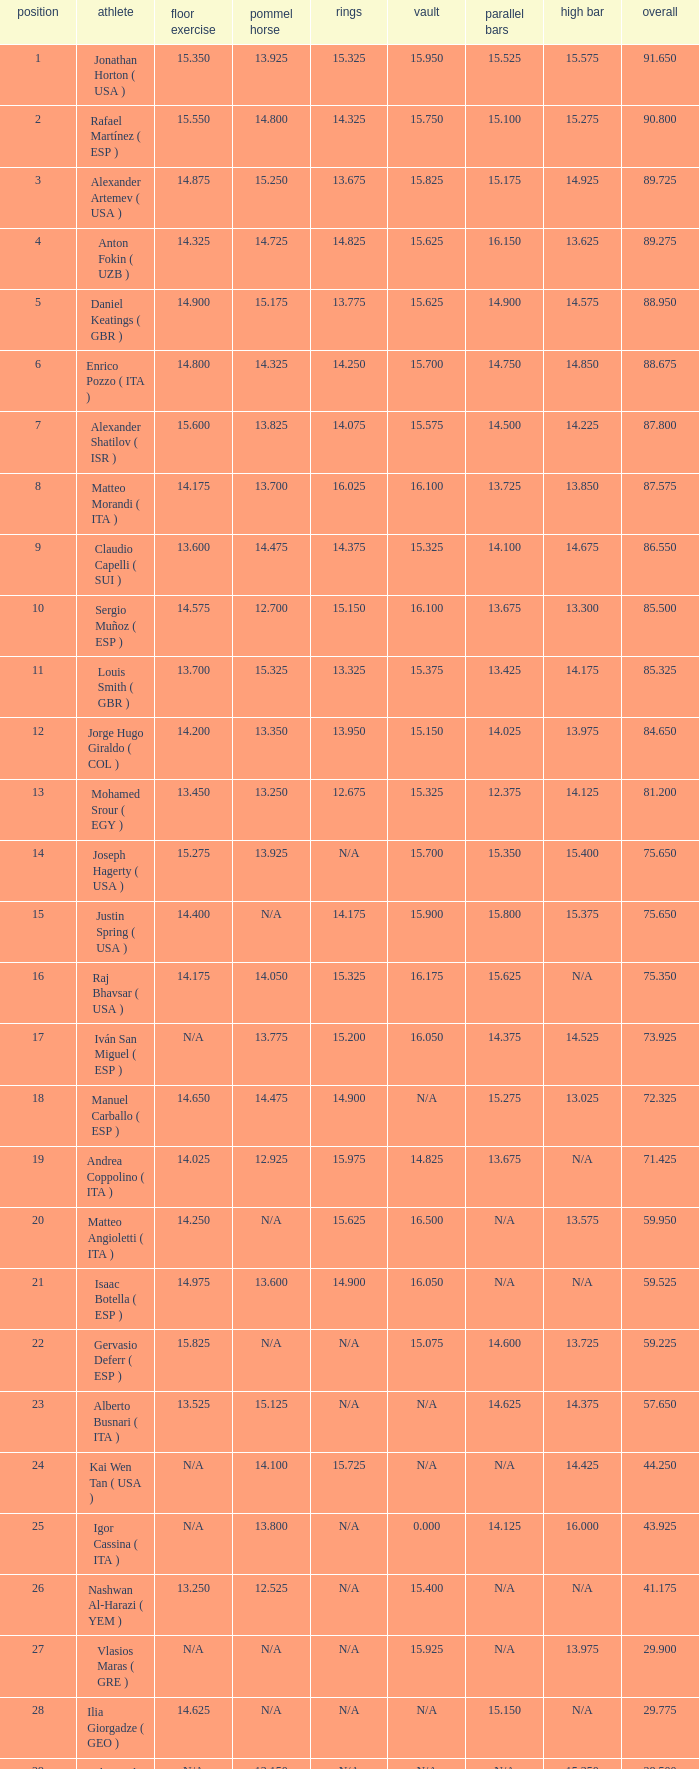If the parallel bars have a length of 1 1.0. 